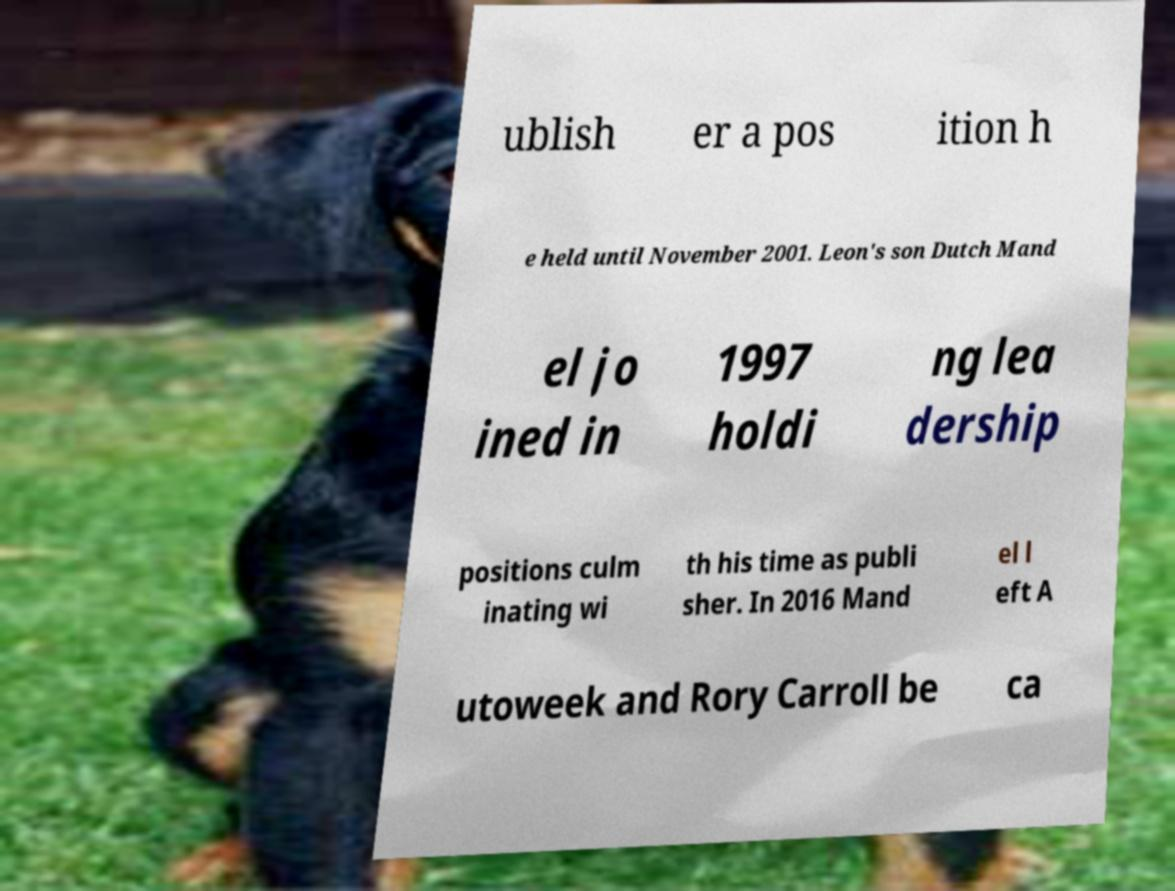Please read and relay the text visible in this image. What does it say? ublish er a pos ition h e held until November 2001. Leon's son Dutch Mand el jo ined in 1997 holdi ng lea dership positions culm inating wi th his time as publi sher. In 2016 Mand el l eft A utoweek and Rory Carroll be ca 